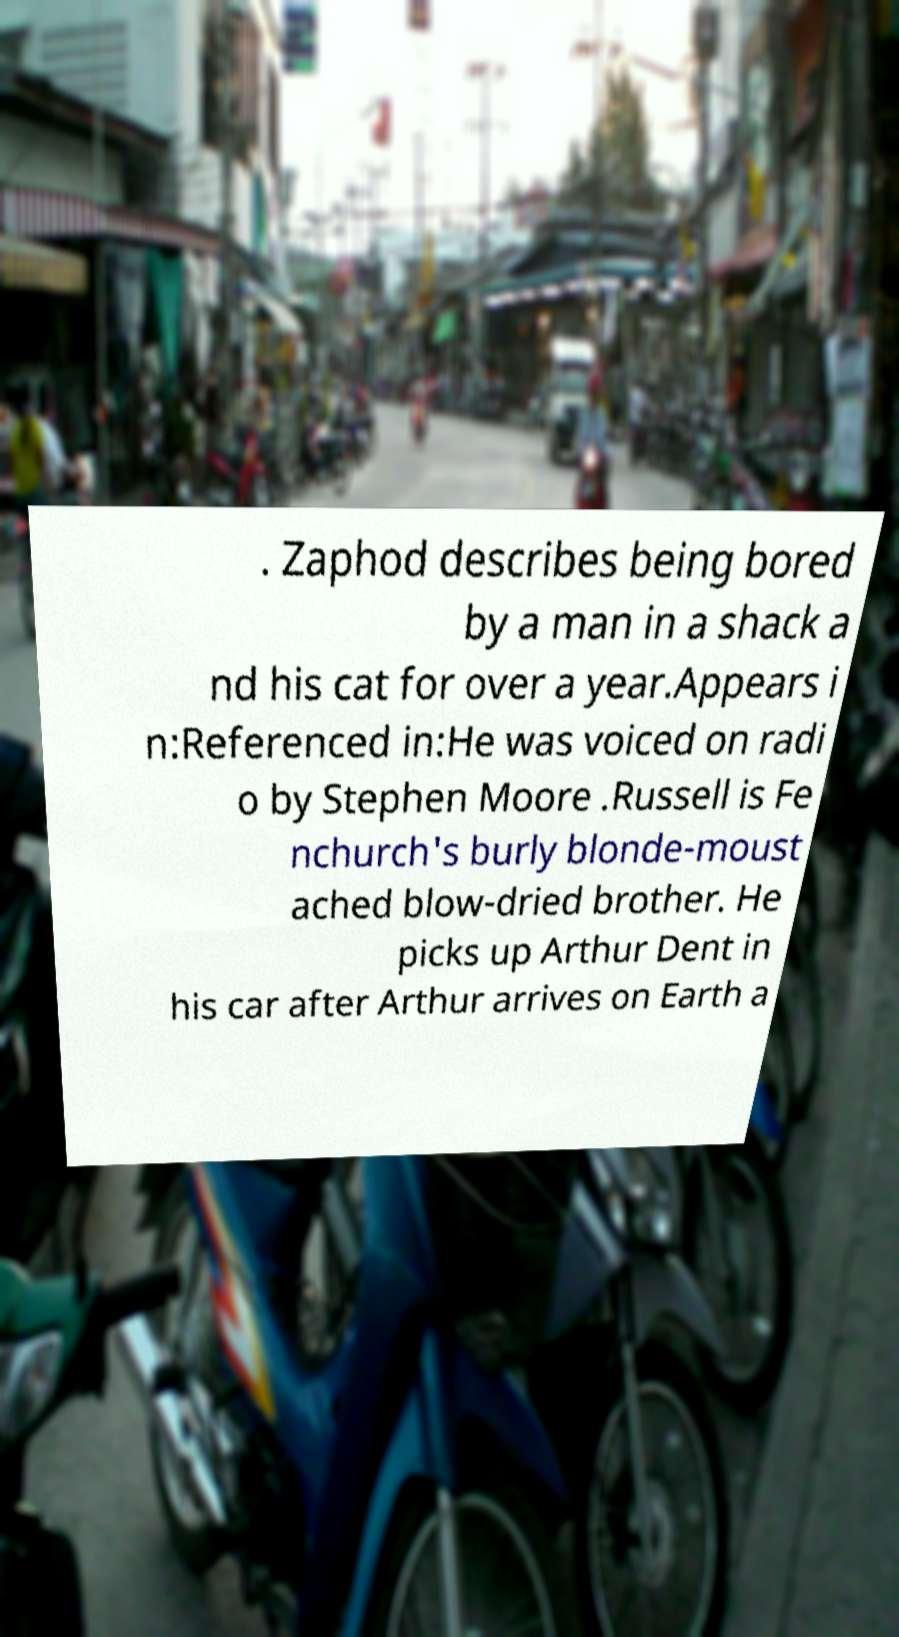I need the written content from this picture converted into text. Can you do that? . Zaphod describes being bored by a man in a shack a nd his cat for over a year.Appears i n:Referenced in:He was voiced on radi o by Stephen Moore .Russell is Fe nchurch's burly blonde-moust ached blow-dried brother. He picks up Arthur Dent in his car after Arthur arrives on Earth a 